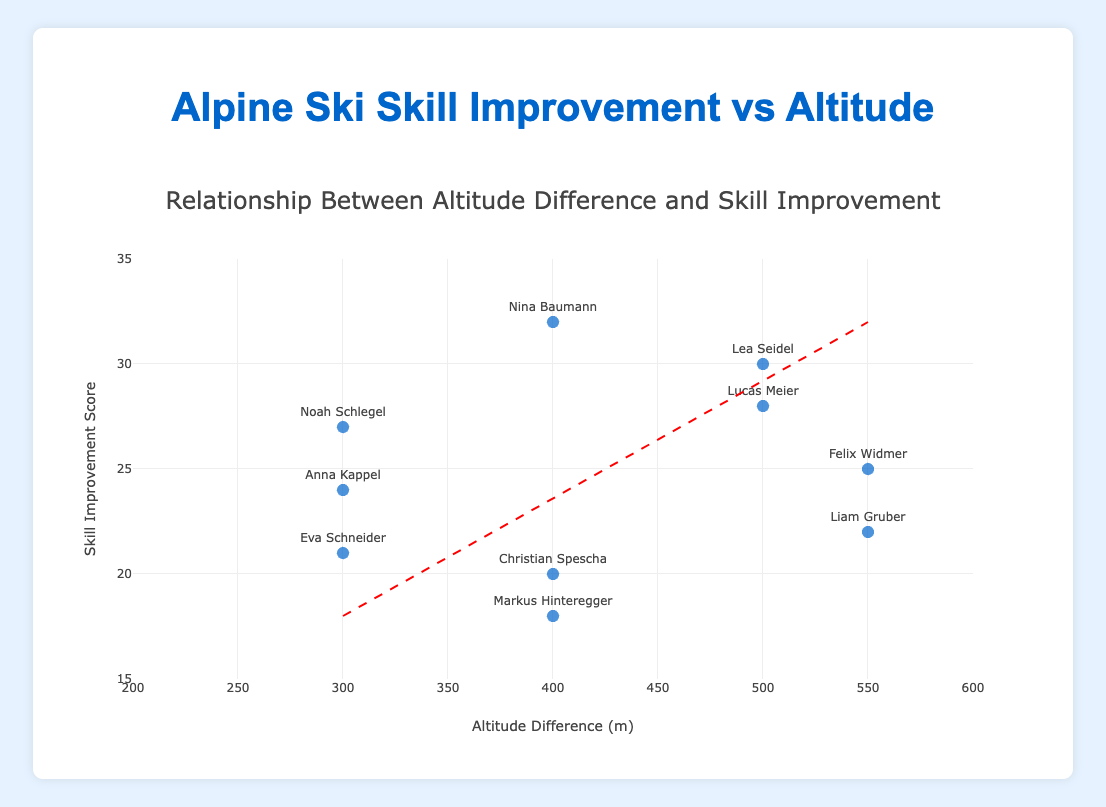How many skiers are represented in the scatter plot? You can count the number of data points (markers) on the plot. Each marker represents a skier.
Answer: 10 What is the title of the scatter plot? The title is usually displayed at the top of the plot. Read it directly from there.
Answer: Relationship Between Altitude Difference and Skill Improvement What is the range of altitude differences in the scatter plot? Look at the x-axis labels to determine the minimum and maximum values representing the altitude differences.
Answer: 200 to 600 meters Which skier showed the highest skill improvement? Identify the data point with the highest value on the y-axis, and read the corresponding skier from the hover text or marker label.
Answer: Nina Baumann Which skier had the smallest altitude difference? Look for the data point closest to the leftmost x-axis value, representing the smallest altitude difference.
Answer: Markus Hinteregger What is the slope of the trend line? The slope can be estimated by observing the angle of the red dashed line. For a precise answer, the trend line equation is necessary, usually provided in the hover text or the plot legend.
Answer: Not explicitly provided in the plot What is the skill improvement score for a 400-meter altitude difference according to the trend line? Find where the x-axis value is 400, then project vertically to intersect the red dashed line, and read the corresponding y-axis value.
Answer: Approximately 23 Compare the skill improvement of Lucas Meier and Lea Seidel. Who improved more? Find the markers for Lucas Meier and Lea Seidel by their hover text or labels. Compare their y-axis values.
Answer: Lea Seidel What is the average skill improvement score for skiers with altitude differences between 300 to 500 meters? Identify the markers between 300 and 500 meters on the x-axis, then calculate the average of their y-axis values.
Answer: (18+21+20+25+27)/5 = 22.2 Is there a general trend between altitude difference and skill improvement? Observe whether the red dashed trend line slopes upwards or downwards, indicating a positive or negative correlation between the variables.
Answer: Positive correlation 